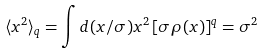Convert formula to latex. <formula><loc_0><loc_0><loc_500><loc_500>\langle x ^ { 2 } \rangle _ { q } = \int d ( x / \sigma ) x ^ { 2 } \, [ \sigma \rho ( x ) ] ^ { q } = \sigma ^ { 2 }</formula> 